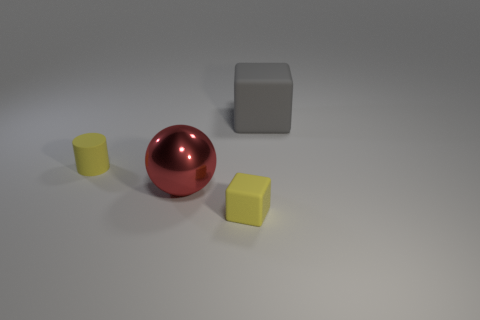Does the matte block that is in front of the gray cube have the same size as the gray object?
Provide a succinct answer. No. There is a rubber thing that is both left of the big gray thing and behind the red shiny ball; what is its shape?
Provide a succinct answer. Cylinder. There is a large block; does it have the same color as the small matte thing that is on the left side of the large metallic ball?
Your response must be concise. No. The big object that is behind the tiny yellow matte thing behind the matte cube that is in front of the shiny object is what color?
Your response must be concise. Gray. The other rubber thing that is the same shape as the gray object is what color?
Provide a short and direct response. Yellow. Are there an equal number of gray objects on the left side of the big metallic sphere and cylinders?
Provide a short and direct response. No. How many balls are either metallic objects or tiny yellow objects?
Provide a short and direct response. 1. What is the color of the cylinder that is the same material as the gray object?
Provide a succinct answer. Yellow. Is the material of the small yellow cube the same as the block behind the cylinder?
Your answer should be compact. Yes. How many things are tiny yellow blocks or purple matte objects?
Offer a terse response. 1. 